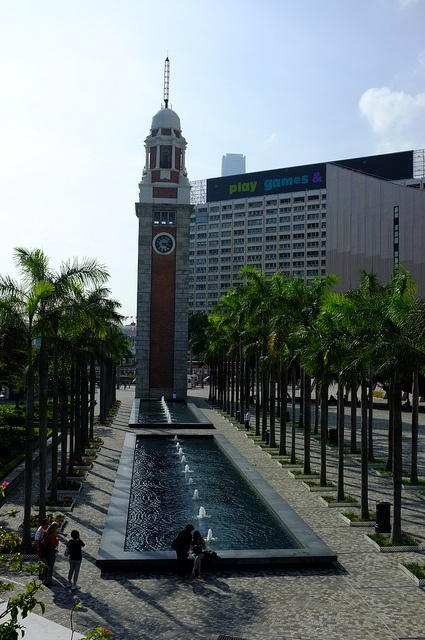Describe the objects in this image and their specific colors. I can see people in white, black, gray, maroon, and darkgreen tones, people in white, black, and gray tones, people in white, black, darkblue, and gray tones, people in white, black, gray, and maroon tones, and clock in white, black, gray, and darkblue tones in this image. 